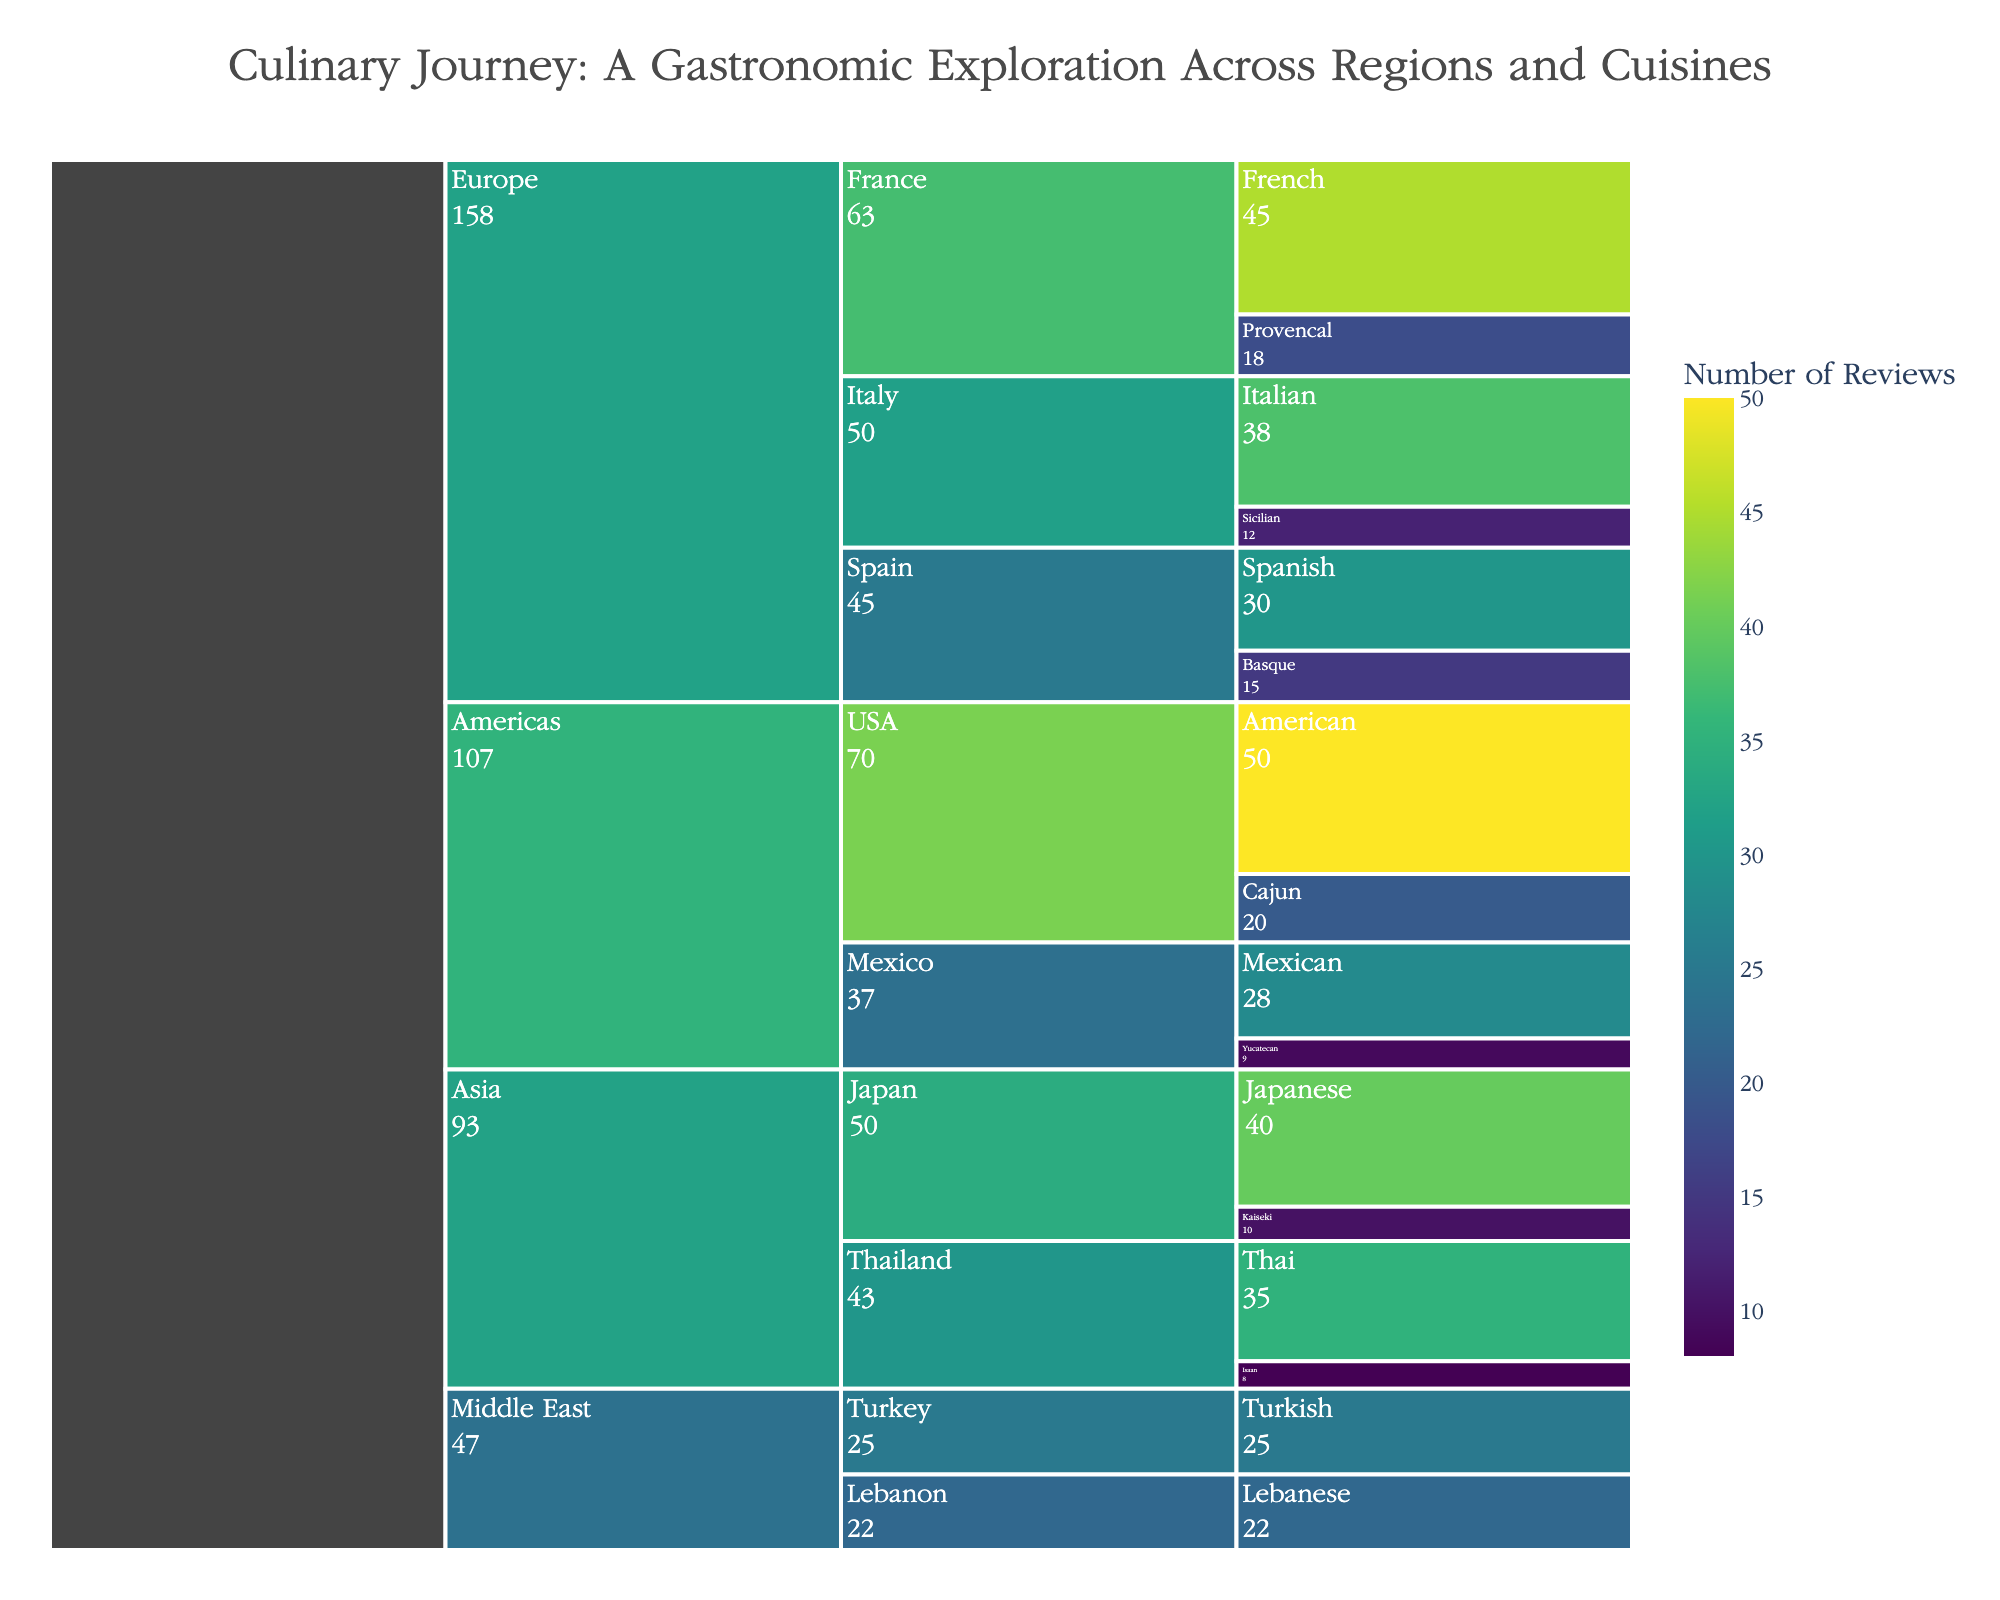How many reviews were there for American cuisine? Locate the "American" cuisine under "USA" within the "Americas" region. The number of reviews is shown next to it.
Answer: 50 Which country in the Europe region has the most reviews? Sum the reviews from each country in the Europe region: France (45+18), Italy (38+12), Spain (30+15). Compare the totals and identify the highest.
Answer: France What is the total number of reviews in the Asia region? Sum all reviews from cuisines within the Asia region: Japan (40+10) and Thailand (35+8). Calculate the total.
Answer: 93 Is there any country that has more than one distinct cuisine reviewed in the Americas? Check the countries within the Americas region: USA has "American" and "Cajun," Mexico has "Mexican" and "Yucatecan." Both countries have multiple cuisines.
Answer: Yes Which country had the least number of reviews for its cuisines in the Middle East region? Compare the total reviews for Lebanon (22) and Turkey (25). Identify the country with the lower total.
Answer: Lebanon What is the combined total of reviews for the Sicilian and Italian cuisines? Locate the reviews for Sicilian (12) and Italian (38) under Italy. Add them together.
Answer: 50 Between France and Spain, which country has fewer reviews for its secondary cuisine? Compare secondary cuisines: Provencal (18) from France and Basque (15) from Spain. Identify the one with fewer reviews.
Answer: Spain Which region has the cuisine with the single highest number of reviews? Identify all cuisines and their review counts, then locate the cuisine with the highest count. This is "American" with 50 reviews, in the Americas region.
Answer: Americas How many countries are there in the Europe region? Check the distinct countries listed under the Europe region: France, Italy, Spain. Count them.
Answer: 3 What is the difference in the number of reviews between Kaiseki and Isaan cuisines? Locate the reviews for Kaiseki (10) and Isaan (8), then subtract the smaller from the larger.
Answer: 2 